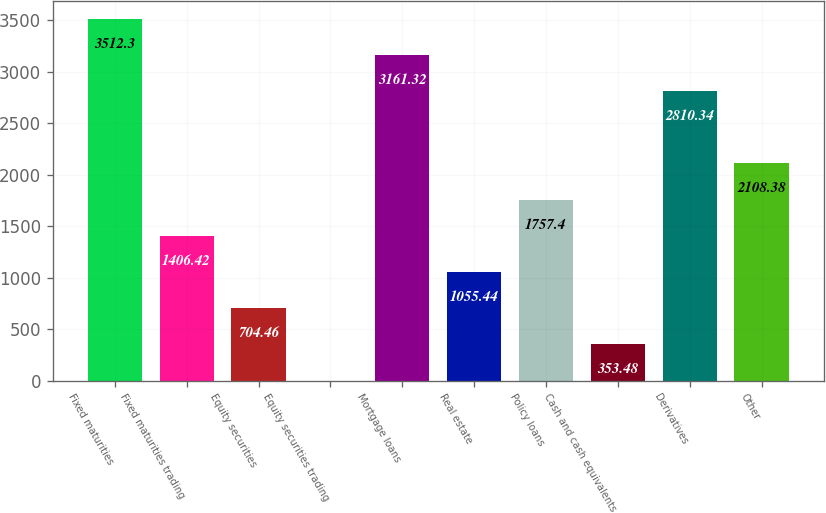Convert chart. <chart><loc_0><loc_0><loc_500><loc_500><bar_chart><fcel>Fixed maturities<fcel>Fixed maturities trading<fcel>Equity securities<fcel>Equity securities trading<fcel>Mortgage loans<fcel>Real estate<fcel>Policy loans<fcel>Cash and cash equivalents<fcel>Derivatives<fcel>Other<nl><fcel>3512.3<fcel>1406.42<fcel>704.46<fcel>2.5<fcel>3161.32<fcel>1055.44<fcel>1757.4<fcel>353.48<fcel>2810.34<fcel>2108.38<nl></chart> 